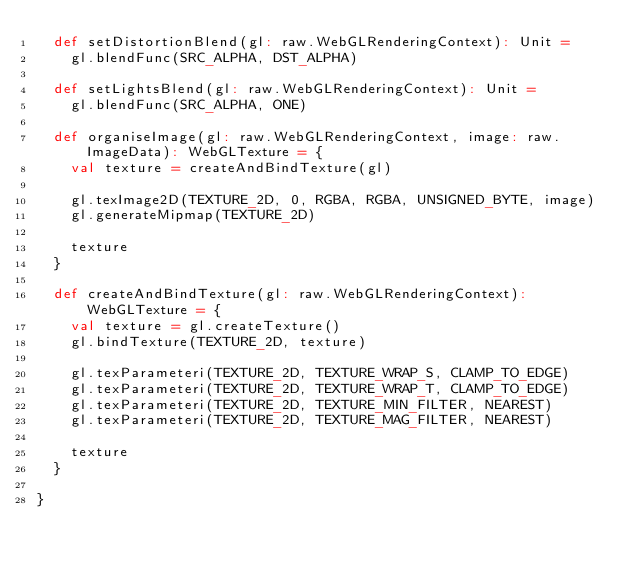Convert code to text. <code><loc_0><loc_0><loc_500><loc_500><_Scala_>  def setDistortionBlend(gl: raw.WebGLRenderingContext): Unit =
    gl.blendFunc(SRC_ALPHA, DST_ALPHA)

  def setLightsBlend(gl: raw.WebGLRenderingContext): Unit =
    gl.blendFunc(SRC_ALPHA, ONE)

  def organiseImage(gl: raw.WebGLRenderingContext, image: raw.ImageData): WebGLTexture = {
    val texture = createAndBindTexture(gl)

    gl.texImage2D(TEXTURE_2D, 0, RGBA, RGBA, UNSIGNED_BYTE, image)
    gl.generateMipmap(TEXTURE_2D)

    texture
  }

  def createAndBindTexture(gl: raw.WebGLRenderingContext): WebGLTexture = {
    val texture = gl.createTexture()
    gl.bindTexture(TEXTURE_2D, texture)

    gl.texParameteri(TEXTURE_2D, TEXTURE_WRAP_S, CLAMP_TO_EDGE)
    gl.texParameteri(TEXTURE_2D, TEXTURE_WRAP_T, CLAMP_TO_EDGE)
    gl.texParameteri(TEXTURE_2D, TEXTURE_MIN_FILTER, NEAREST)
    gl.texParameteri(TEXTURE_2D, TEXTURE_MAG_FILTER, NEAREST)

    texture
  }

}
</code> 